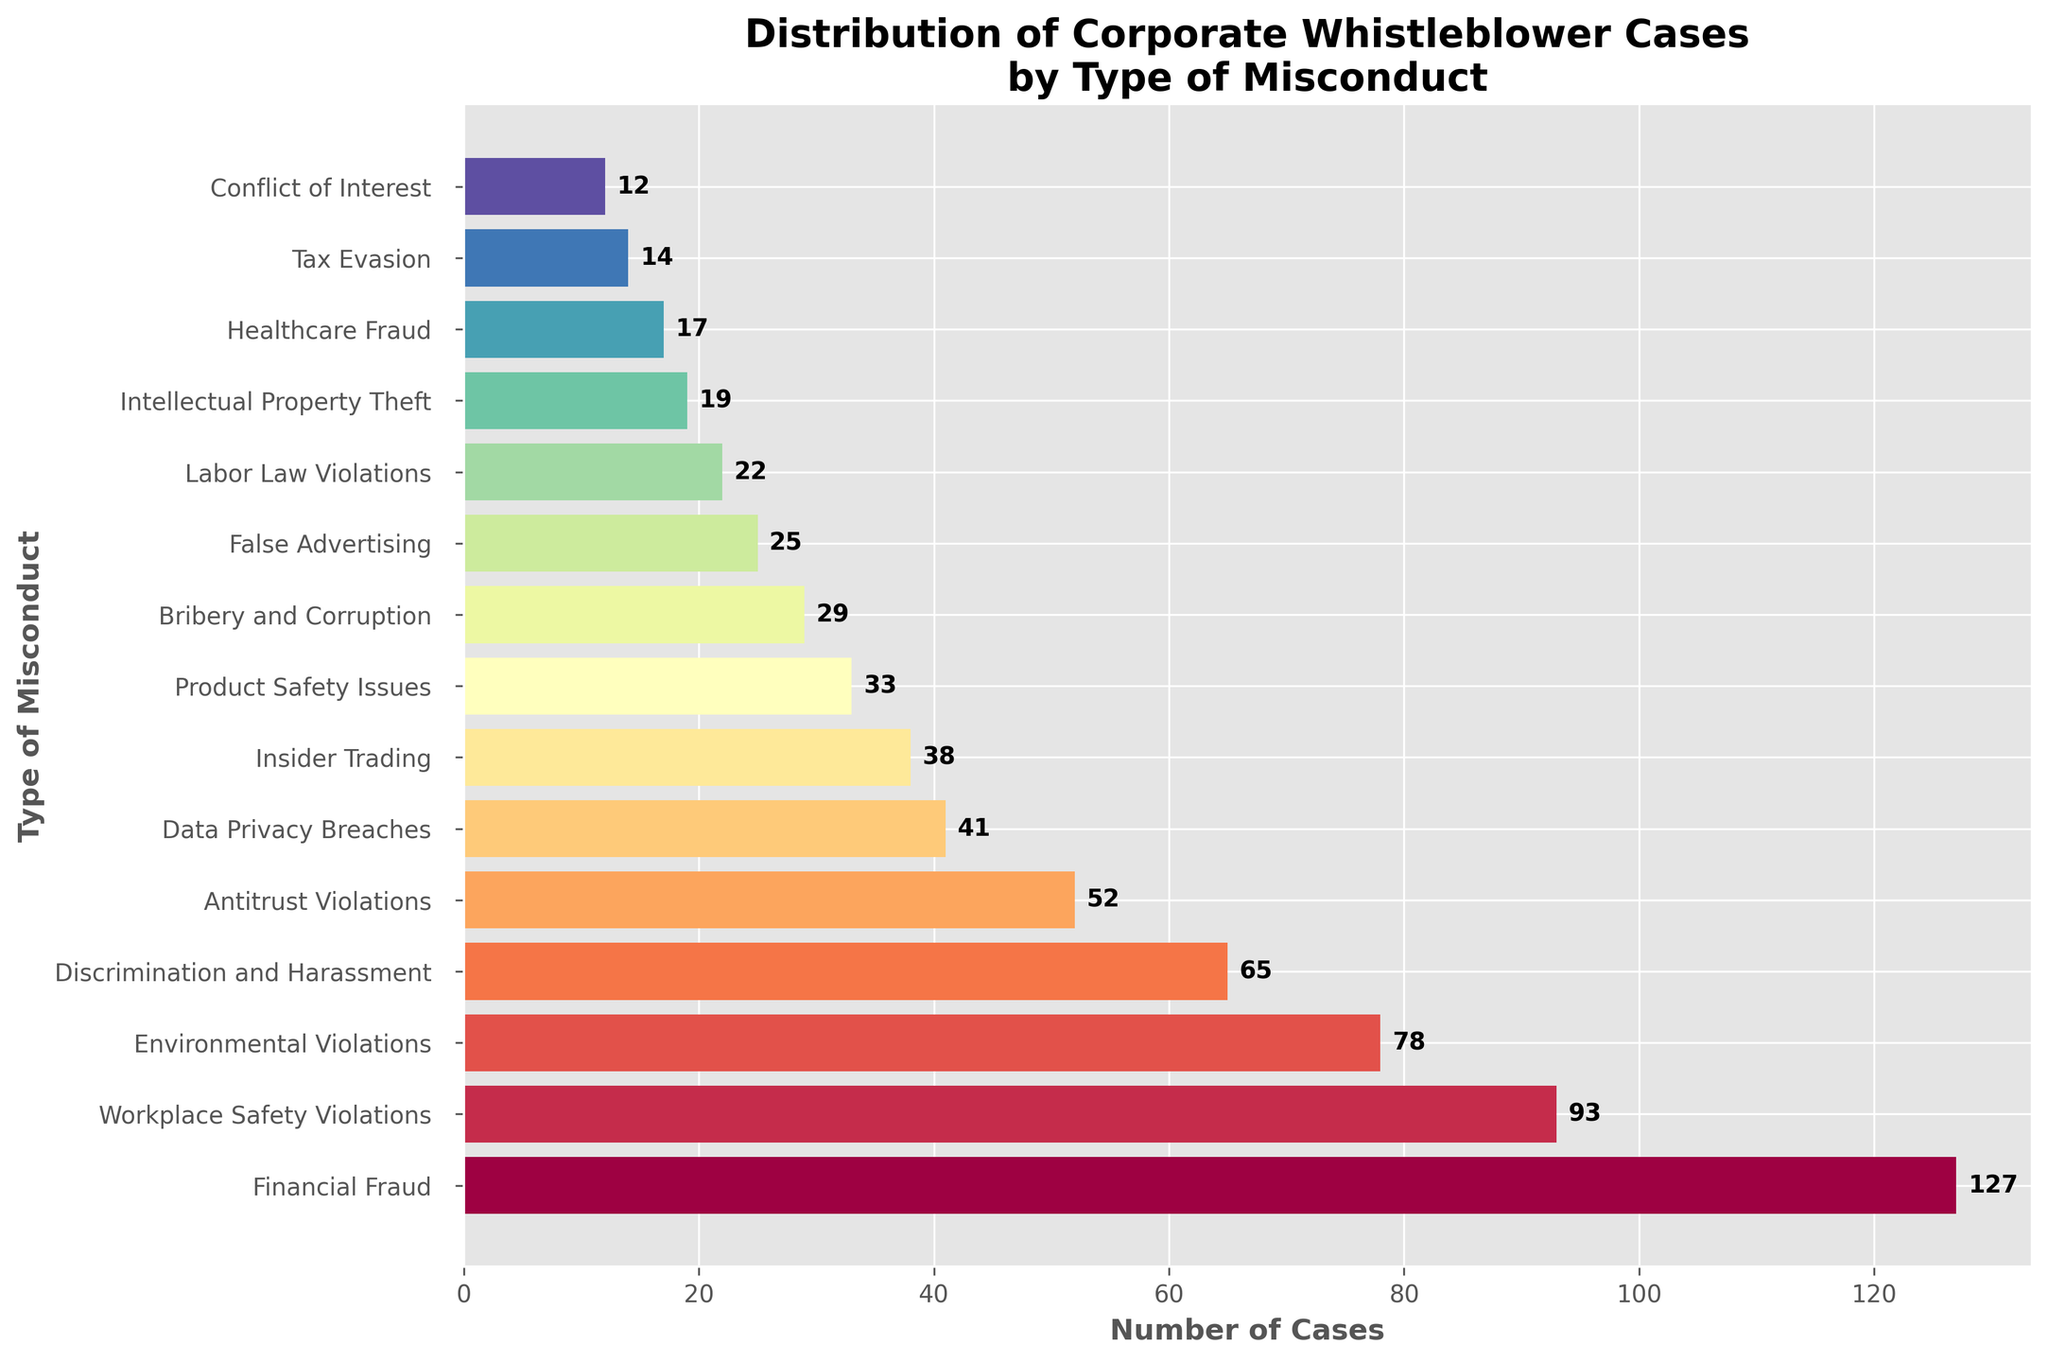Which type of misconduct has the highest number of whistleblower cases? The bar representing Financial Fraud has the greatest length, indicating it has the highest number of cases.
Answer: Financial Fraud How many more cases are there for Workplace Safety Violations than for Conflict of Interest? Workplace Safety Violations have 93 cases, and Conflict of Interest has 12 cases. The difference is 93 - 12 = 81.
Answer: 81 What is the total number of whistleblower cases for Bribery and Corruption, False Advertising, and Labor Law Violations combined? Bribery and Corruption have 29 cases, False Advertising has 25 cases, and Labor Law Violations have 22 cases. The total is 29 + 25 + 22 = 76.
Answer: 76 Which type of misconduct has fewer cases, Data Privacy Breaches or Insider Trading? Data Privacy Breaches have 41 cases, and Insider Trading has 38 cases. Insider Trading has fewer cases.
Answer: Insider Trading What is the combined number of cases for the types of misconduct that have over 70 cases each? The types of misconduct that have over 70 cases are Financial Fraud (127), Workplace Safety Violations (93), and Environmental Violations (78). The total is 127 + 93 + 78 = 298.
Answer: 298 What is the visual color sequence from the bar with the fewest cases to the bar with the most cases? The bar with the fewest cases (Conflict of Interest) is shown in a lighter color, likely in the pastel range, progressing to varied hues towards Financial Fraud, which has the most cases.
Answer: Light to varied hues Which two categories have the closest number of cases, and what are their numbers? Insider Trading has 38 cases, and Data Privacy Breaches have 41 cases. The difference between them is small, only 3 cases.
Answer: Insider Trading and Data Privacy Breaches; 38 and 41 cases By how much do Environmental Violations exceed Healthcare Fraud in the number of cases? Environmental Violations have 78 cases, and Healthcare Fraud has 17 cases. The difference is 78 - 17 = 61.
Answer: 61 What is the average number of cases for Discrimination and Harassment and Antitrust Violations? Discrimination and Harassment have 65 cases, and Antitrust Violations have 52 cases. The average is (65 + 52) / 2 = 117 / 2 = 58.5.
Answer: 58.5 How does the number of cases for Product Safety Issues compare with Intellectual Property Theft? Product Safety Issues have 33 cases, and Intellectual Property Theft has 19 cases. Product Safety Issues have 33 - 19 = 14 more cases.
Answer: 14 more cases 